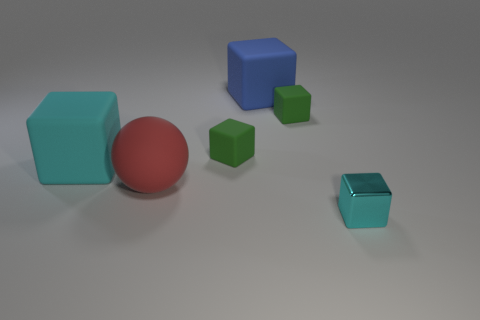There is a big rubber object that is the same color as the tiny metal block; what shape is it?
Give a very brief answer. Cube. The matte block that is the same color as the small metallic object is what size?
Your answer should be compact. Large. What number of other objects are there of the same size as the metal block?
Offer a very short reply. 2. The tiny block that is in front of the large rubber object in front of the cyan block that is behind the small metal block is what color?
Provide a short and direct response. Cyan. How many other things are there of the same shape as the red object?
Your response must be concise. 0. The rubber object to the right of the blue cube has what shape?
Offer a terse response. Cube. There is a cyan object that is behind the small cyan metallic object; is there a red rubber object that is to the left of it?
Provide a short and direct response. No. There is a thing that is in front of the cyan rubber block and to the left of the cyan metal object; what color is it?
Give a very brief answer. Red. Are there any spheres that are behind the cyan thing that is to the left of the cyan block in front of the large cyan matte cube?
Offer a very short reply. No. There is a cyan matte object that is the same shape as the small metal object; what is its size?
Make the answer very short. Large. 